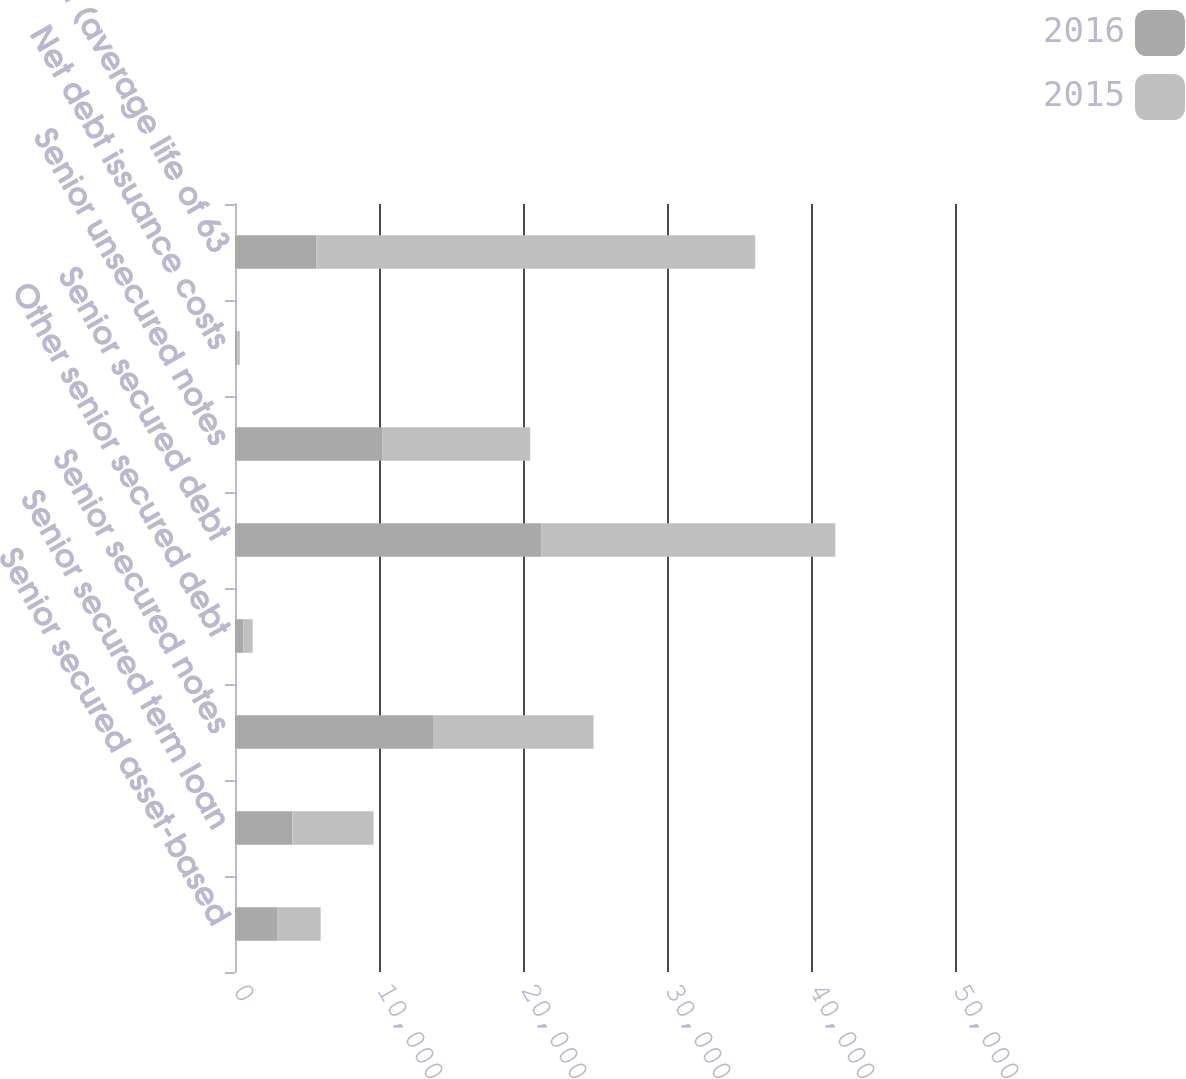Convert chart to OTSL. <chart><loc_0><loc_0><loc_500><loc_500><stacked_bar_chart><ecel><fcel>Senior secured asset-based<fcel>Senior secured term loan<fcel>Senior secured notes<fcel>Other senior secured debt<fcel>Senior secured debt<fcel>Senior unsecured notes<fcel>Net debt issuance costs<fcel>Total debt (average life of 63<nl><fcel>2016<fcel>2920<fcel>3981<fcel>13800<fcel>593<fcel>21294<fcel>10252<fcel>170<fcel>5639<nl><fcel>2015<fcel>3030<fcel>5639<fcel>11100<fcel>634<fcel>20403<fcel>10252<fcel>167<fcel>30488<nl></chart> 